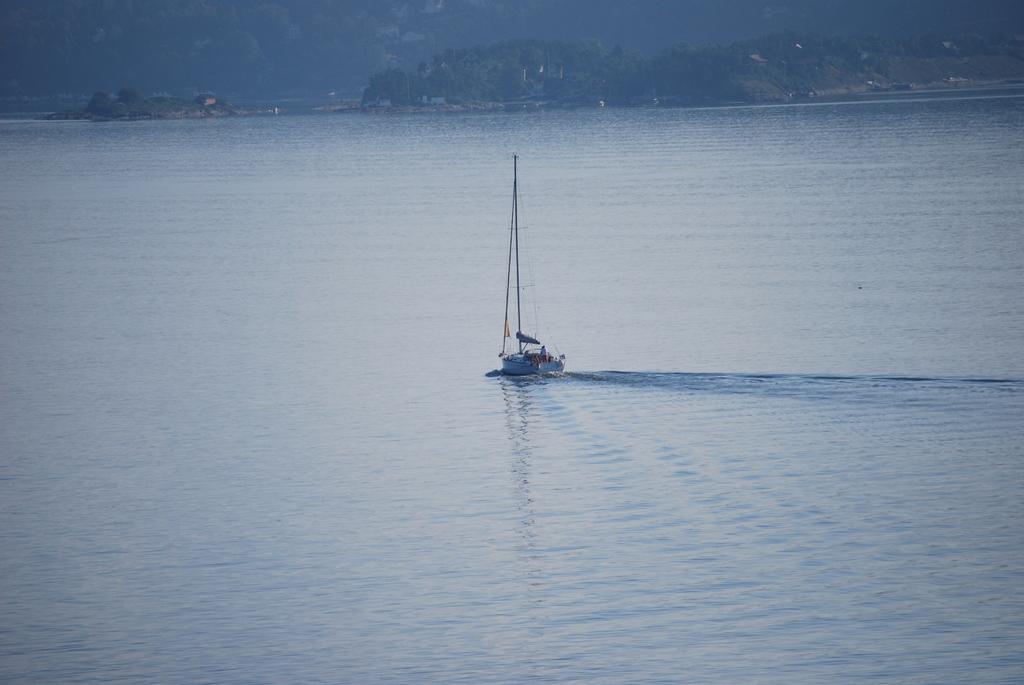Could you give a brief overview of what you see in this image? In the picture we can see a water surface on it, we can see a boat with a pole and wire to it and far away from it we can see some hills with trees and houses near it. 